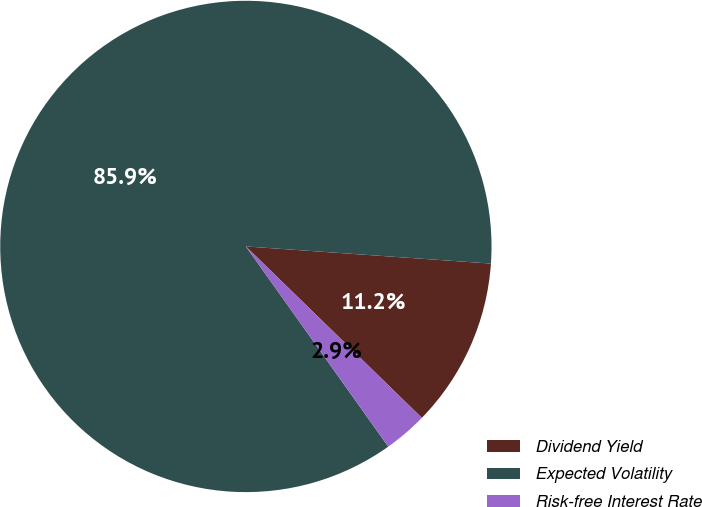Convert chart. <chart><loc_0><loc_0><loc_500><loc_500><pie_chart><fcel>Dividend Yield<fcel>Expected Volatility<fcel>Risk-free Interest Rate<nl><fcel>11.18%<fcel>85.95%<fcel>2.87%<nl></chart> 